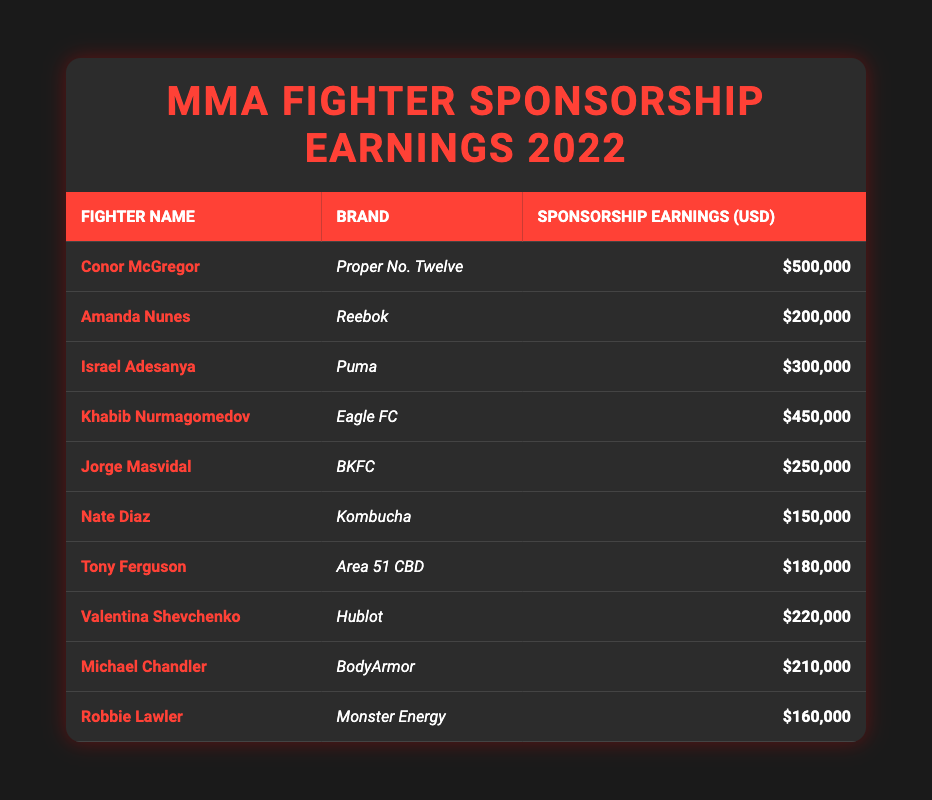What is the highest sponsorship earning by an MMA fighter in 2022? Looking at the table, Conor McGregor has the highest sponsorship earning of $500,000 from Proper No. Twelve.
Answer: $500,000 Which brand sponsored the fighter with the second-highest earnings? The fighter with the second-highest earnings is Khabib Nurmagomedov, who earned $450,000 from Eagle FC.
Answer: Eagle FC What is the total sponsorship earnings of all fighters listed in the table? To find the total earnings, we sum up all the earnings: 500,000 + 200,000 + 300,000 + 450,000 + 250,000 + 150,000 + 180,000 + 220,000 + 210,000 + 160,000 = 2,520,000.
Answer: $2,520,000 Did Amanda Nunes earn more than Tony Ferguson? Amanda Nunes earned $200,000 while Tony Ferguson earned $180,000; therefore, yes, Nunes earned more.
Answer: Yes What is the average sponsorship earning across all fighters? There are 10 fighters total. The total earnings are $2,520,000, so the average is calculated as $2,520,000 / 10 = $252,000.
Answer: $252,000 Which brands have earnings higher than $200,000? The brands with earnings higher than $200,000 are Proper No. Twelve, Eagle FC, and Puma, associated with Conor McGregor, Khabib Nurmagomedov, and Israel Adesanya respectively.
Answer: Proper No. Twelve, Eagle FC, Puma Is there any fighter who earned exactly $210,000? Yes, Michael Chandler earned exactly $210,000 from BodyArmor, confirming there is a fighter with that earning.
Answer: Yes How many fighters earned less than $200,000? The fighters who earned less than $200,000 are Nate Diaz ($150,000), Tony Ferguson ($180,000), and Robbie Lawler ($160,000). Therefore, there are 3 fighters.
Answer: 3 What is the difference in sponsorship earnings between Conor McGregor and Amanda Nunes? Conor McGregor earned $500,000 while Amanda Nunes earned $200,000. The difference is calculated as $500,000 - $200,000 = $300,000.
Answer: $300,000 Which fighter had the lowest earnings in 2022? Nate Diaz had the lowest earnings at $150,000 from Kombucha, making him the fighter with the least earnings in 2022.
Answer: Nate Diaz 